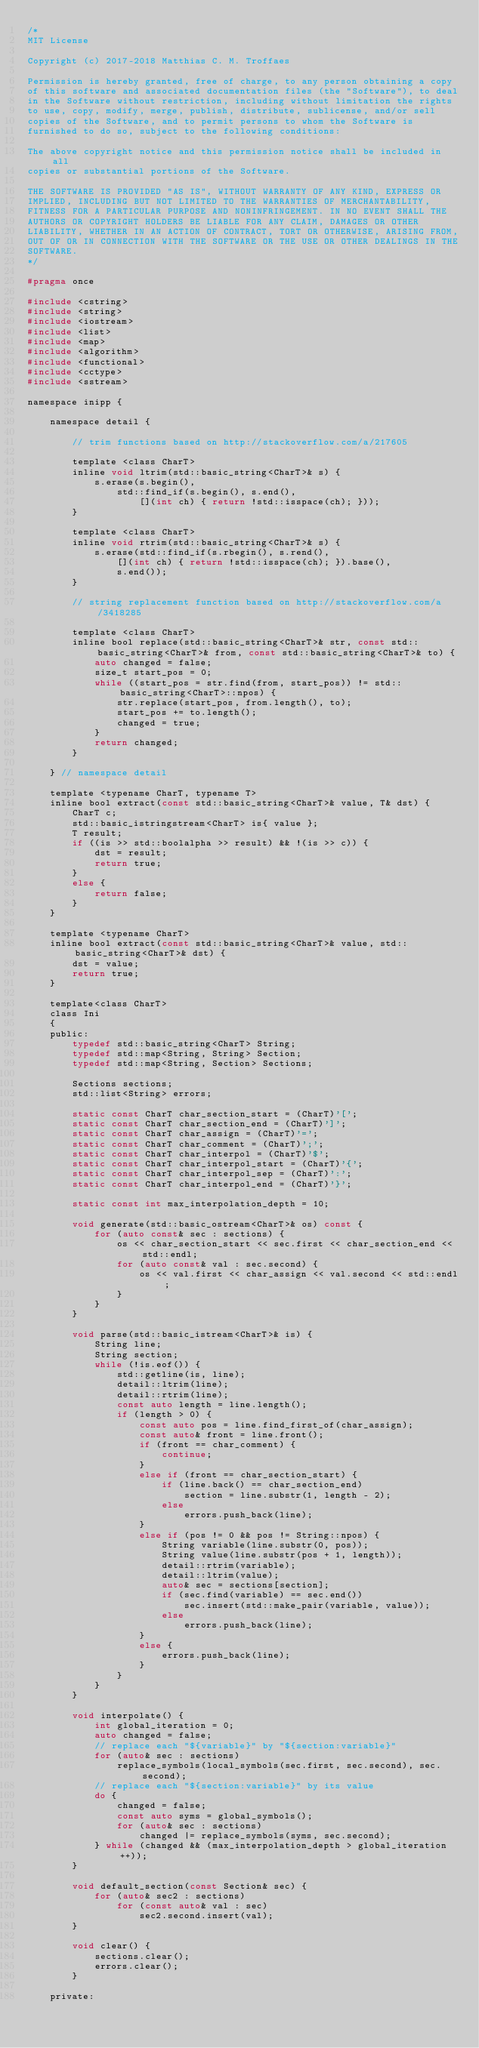<code> <loc_0><loc_0><loc_500><loc_500><_C_>/*
MIT License

Copyright (c) 2017-2018 Matthias C. M. Troffaes

Permission is hereby granted, free of charge, to any person obtaining a copy
of this software and associated documentation files (the "Software"), to deal
in the Software without restriction, including without limitation the rights
to use, copy, modify, merge, publish, distribute, sublicense, and/or sell
copies of the Software, and to permit persons to whom the Software is
furnished to do so, subject to the following conditions:

The above copyright notice and this permission notice shall be included in all
copies or substantial portions of the Software.

THE SOFTWARE IS PROVIDED "AS IS", WITHOUT WARRANTY OF ANY KIND, EXPRESS OR
IMPLIED, INCLUDING BUT NOT LIMITED TO THE WARRANTIES OF MERCHANTABILITY,
FITNESS FOR A PARTICULAR PURPOSE AND NONINFRINGEMENT. IN NO EVENT SHALL THE
AUTHORS OR COPYRIGHT HOLDERS BE LIABLE FOR ANY CLAIM, DAMAGES OR OTHER
LIABILITY, WHETHER IN AN ACTION OF CONTRACT, TORT OR OTHERWISE, ARISING FROM,
OUT OF OR IN CONNECTION WITH THE SOFTWARE OR THE USE OR OTHER DEALINGS IN THE
SOFTWARE.
*/

#pragma once

#include <cstring>
#include <string>
#include <iostream>
#include <list>
#include <map>
#include <algorithm>
#include <functional>
#include <cctype>
#include <sstream>

namespace inipp {

	namespace detail {

		// trim functions based on http://stackoverflow.com/a/217605

		template <class CharT>
		inline void ltrim(std::basic_string<CharT>& s) {
			s.erase(s.begin(),
				std::find_if(s.begin(), s.end(),
					[](int ch) { return !std::isspace(ch); }));
		}

		template <class CharT>
		inline void rtrim(std::basic_string<CharT>& s) {
			s.erase(std::find_if(s.rbegin(), s.rend(),
				[](int ch) { return !std::isspace(ch); }).base(),
				s.end());
		}

		// string replacement function based on http://stackoverflow.com/a/3418285

		template <class CharT>
		inline bool replace(std::basic_string<CharT>& str, const std::basic_string<CharT>& from, const std::basic_string<CharT>& to) {
			auto changed = false;
			size_t start_pos = 0;
			while ((start_pos = str.find(from, start_pos)) != std::basic_string<CharT>::npos) {
				str.replace(start_pos, from.length(), to);
				start_pos += to.length();
				changed = true;
			}
			return changed;
		}

	} // namespace detail

	template <typename CharT, typename T>
	inline bool extract(const std::basic_string<CharT>& value, T& dst) {
		CharT c;
		std::basic_istringstream<CharT> is{ value };
		T result;
		if ((is >> std::boolalpha >> result) && !(is >> c)) {
			dst = result;
			return true;
		}
		else {
			return false;
		}
	}

	template <typename CharT>
	inline bool extract(const std::basic_string<CharT>& value, std::basic_string<CharT>& dst) {
		dst = value;
		return true;
	}

	template<class CharT>
	class Ini
	{
	public:
		typedef std::basic_string<CharT> String;
		typedef std::map<String, String> Section;
		typedef std::map<String, Section> Sections;

		Sections sections;
		std::list<String> errors;

		static const CharT char_section_start = (CharT)'[';
		static const CharT char_section_end = (CharT)']';
		static const CharT char_assign = (CharT)'=';
		static const CharT char_comment = (CharT)';';
		static const CharT char_interpol = (CharT)'$';
		static const CharT char_interpol_start = (CharT)'{';
		static const CharT char_interpol_sep = (CharT)':';
		static const CharT char_interpol_end = (CharT)'}';

		static const int max_interpolation_depth = 10;

		void generate(std::basic_ostream<CharT>& os) const {
			for (auto const& sec : sections) {
				os << char_section_start << sec.first << char_section_end << std::endl;
				for (auto const& val : sec.second) {
					os << val.first << char_assign << val.second << std::endl;
				}
			}
		}

		void parse(std::basic_istream<CharT>& is) {
			String line;
			String section;
			while (!is.eof()) {
				std::getline(is, line);
				detail::ltrim(line);
				detail::rtrim(line);
				const auto length = line.length();
				if (length > 0) {
					const auto pos = line.find_first_of(char_assign);
					const auto& front = line.front();
					if (front == char_comment) {
						continue;
					}
					else if (front == char_section_start) {
						if (line.back() == char_section_end)
							section = line.substr(1, length - 2);
						else
							errors.push_back(line);
					}
					else if (pos != 0 && pos != String::npos) {
						String variable(line.substr(0, pos));
						String value(line.substr(pos + 1, length));
						detail::rtrim(variable);
						detail::ltrim(value);
						auto& sec = sections[section];
						if (sec.find(variable) == sec.end())
							sec.insert(std::make_pair(variable, value));
						else
							errors.push_back(line);
					}
					else {
						errors.push_back(line);
					}
				}
			}
		}

		void interpolate() {
			int global_iteration = 0;
			auto changed = false;
			// replace each "${variable}" by "${section:variable}"
			for (auto& sec : sections)
				replace_symbols(local_symbols(sec.first, sec.second), sec.second);
			// replace each "${section:variable}" by its value
			do {
				changed = false;
				const auto syms = global_symbols();
				for (auto& sec : sections)
					changed |= replace_symbols(syms, sec.second);
			} while (changed && (max_interpolation_depth > global_iteration++));
		}

		void default_section(const Section& sec) {
			for (auto& sec2 : sections)
				for (const auto& val : sec)
					sec2.second.insert(val);
		}

		void clear() {
			sections.clear();
			errors.clear();
		}

	private:</code> 